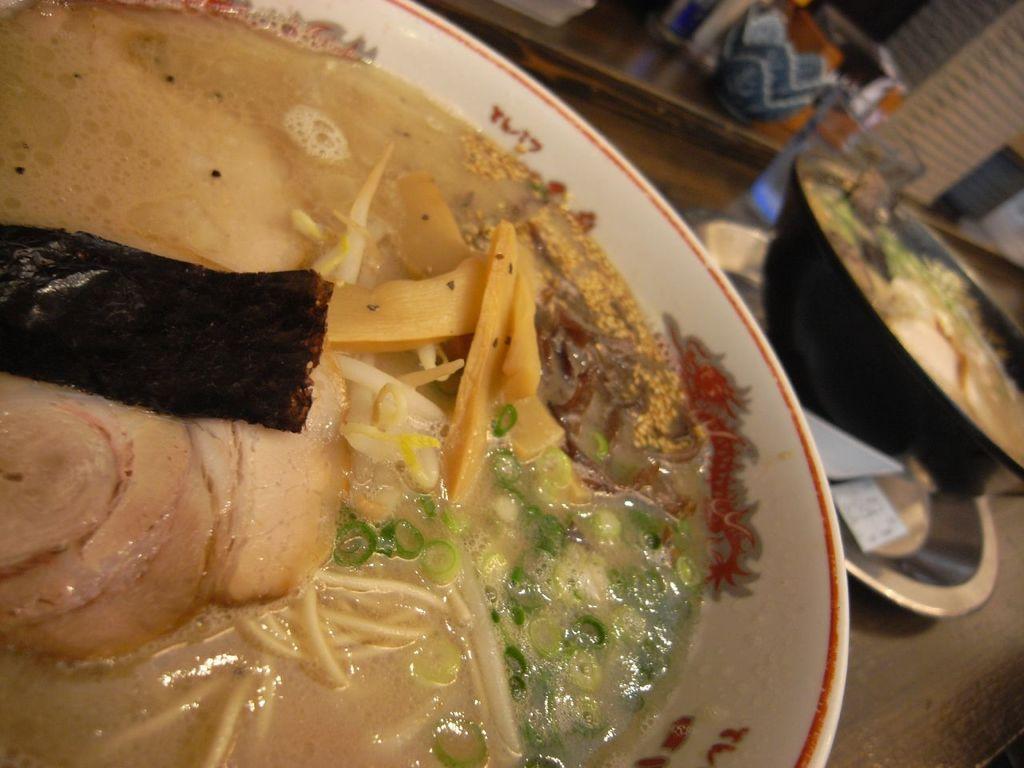Describe this image in one or two sentences. In this image, there are food items in the bowls. I can see a glass, plate and few other objects on the table. 